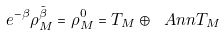Convert formula to latex. <formula><loc_0><loc_0><loc_500><loc_500>e ^ { - \beta } \rho ^ { \tilde { \beta } } _ { M } = \rho ^ { 0 } _ { M } = T _ { M } \oplus \ A n n T _ { M }</formula> 